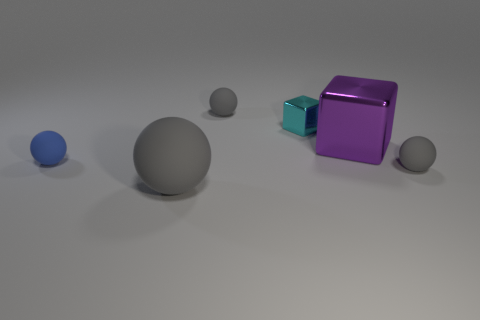Subtract all red cylinders. How many gray spheres are left? 3 Add 1 tiny gray shiny cylinders. How many objects exist? 7 Subtract all spheres. How many objects are left? 2 Subtract 0 green spheres. How many objects are left? 6 Subtract all large gray matte balls. Subtract all small purple metal cylinders. How many objects are left? 5 Add 2 gray objects. How many gray objects are left? 5 Add 4 things. How many things exist? 10 